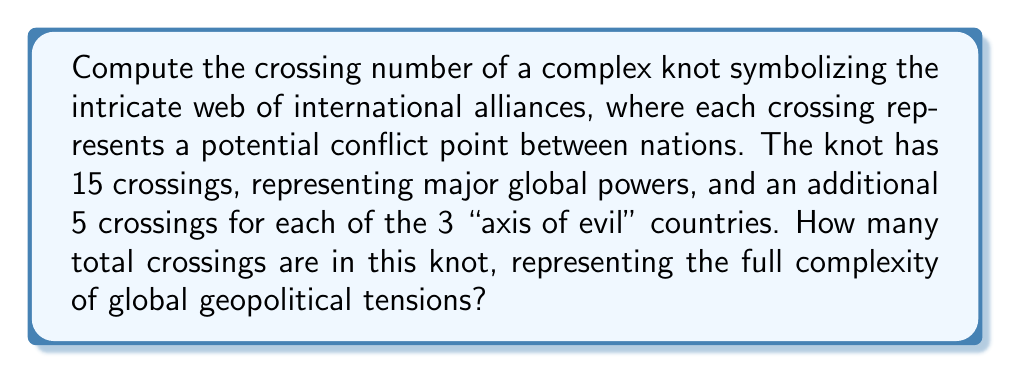Help me with this question. To solve this problem, we need to follow these steps:

1. Identify the base number of crossings:
   The knot starts with 15 crossings, representing major global powers.

2. Calculate the additional crossings for "axis of evil" countries:
   - There are 3 "axis of evil" countries
   - Each contributes 5 additional crossings
   - Total additional crossings = $3 \times 5 = 15$

3. Sum up the total crossings:
   $$\text{Total crossings} = \text{Base crossings} + \text{Additional crossings}$$
   $$\text{Total crossings} = 15 + 15 = 30$$

This result symbolizes the complex nature of international relations, where each crossing point represents a potential flashpoint for conflict or diplomatic tension. The higher number of crossings for "axis of evil" countries reflects the increased complexity and potential for conflict in dealing with these nations from the perspective of a Russophobic, interventionist conservative.
Answer: 30 crossings 